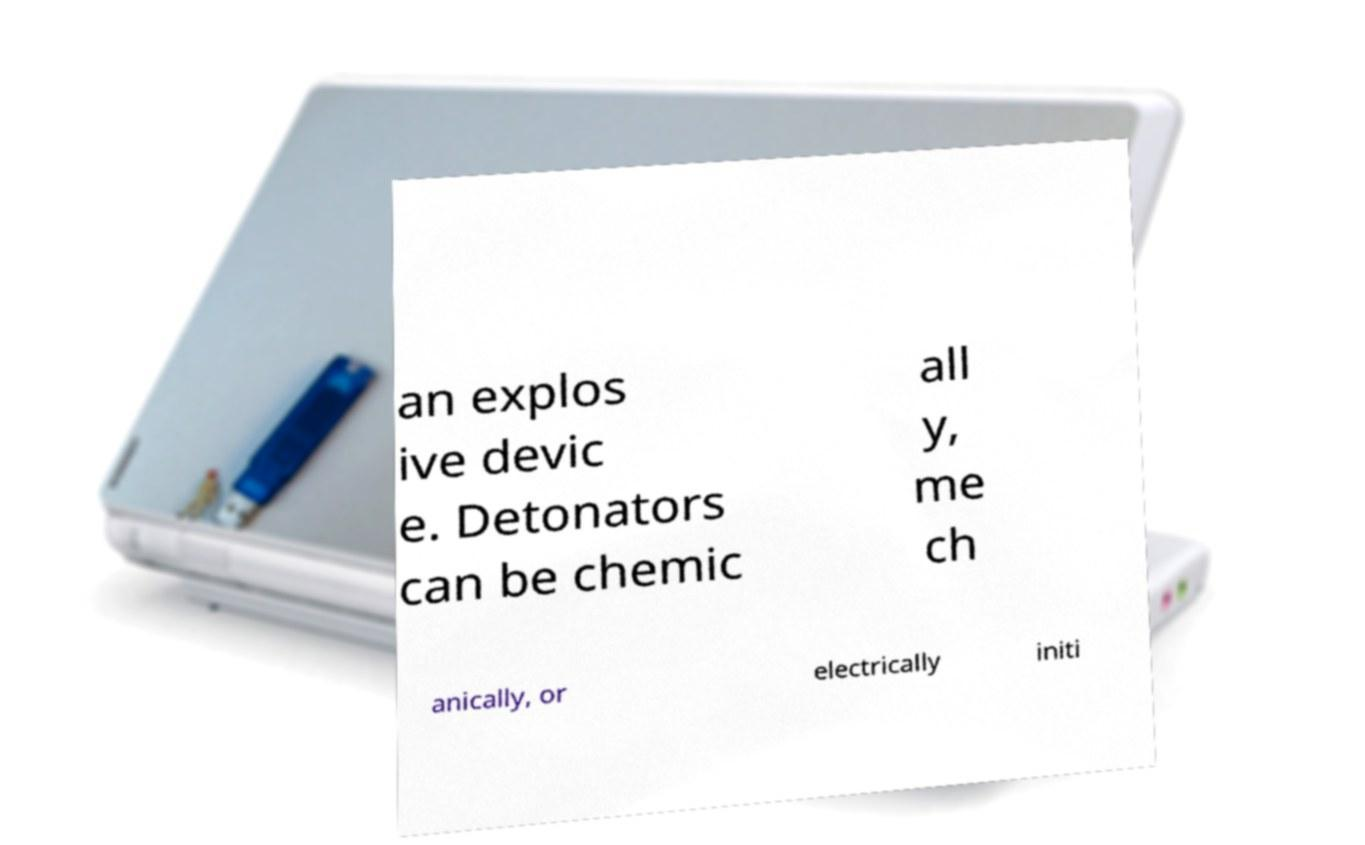There's text embedded in this image that I need extracted. Can you transcribe it verbatim? an explos ive devic e. Detonators can be chemic all y, me ch anically, or electrically initi 